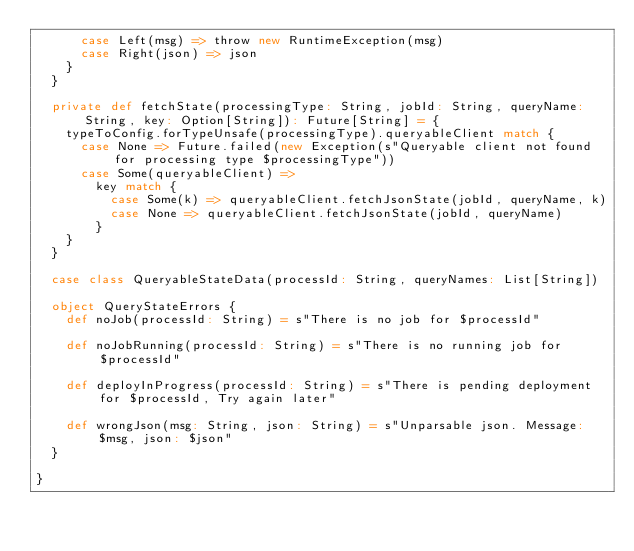Convert code to text. <code><loc_0><loc_0><loc_500><loc_500><_Scala_>      case Left(msg) => throw new RuntimeException(msg)
      case Right(json) => json
    }
  }

  private def fetchState(processingType: String, jobId: String, queryName: String, key: Option[String]): Future[String] = {
    typeToConfig.forTypeUnsafe(processingType).queryableClient match {
      case None => Future.failed(new Exception(s"Queryable client not found for processing type $processingType"))
      case Some(queryableClient) =>
        key match {
          case Some(k) => queryableClient.fetchJsonState(jobId, queryName, k)
          case None => queryableClient.fetchJsonState(jobId, queryName)
        }
    }
  }

  case class QueryableStateData(processId: String, queryNames: List[String])

  object QueryStateErrors {
    def noJob(processId: String) = s"There is no job for $processId"

    def noJobRunning(processId: String) = s"There is no running job for $processId"

    def deployInProgress(processId: String) = s"There is pending deployment for $processId, Try again later"

    def wrongJson(msg: String, json: String) = s"Unparsable json. Message: $msg, json: $json"
  }

}
</code> 